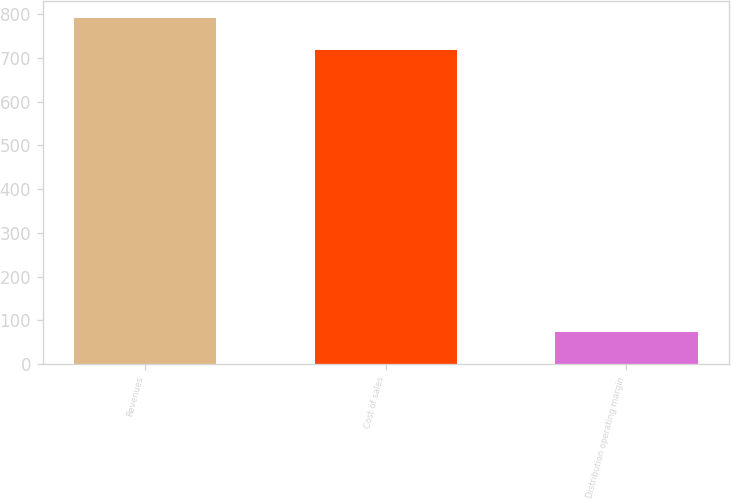<chart> <loc_0><loc_0><loc_500><loc_500><bar_chart><fcel>Revenues<fcel>Cost of sales<fcel>Distribution operating margin<nl><fcel>792<fcel>718.9<fcel>73.1<nl></chart> 